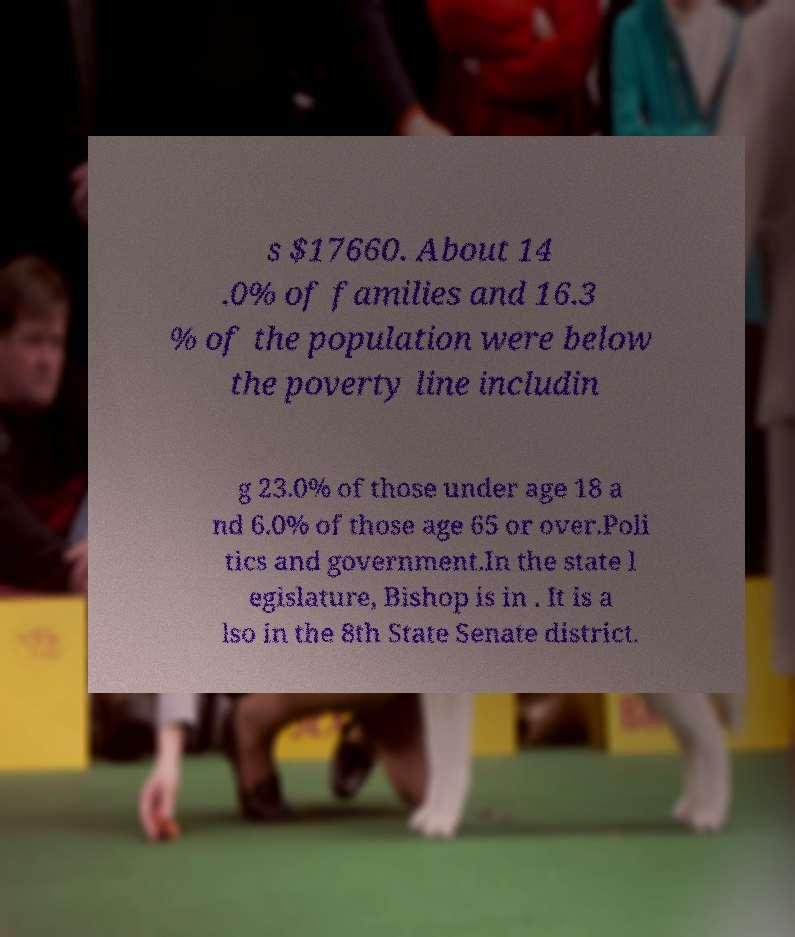Please identify and transcribe the text found in this image. s $17660. About 14 .0% of families and 16.3 % of the population were below the poverty line includin g 23.0% of those under age 18 a nd 6.0% of those age 65 or over.Poli tics and government.In the state l egislature, Bishop is in . It is a lso in the 8th State Senate district. 